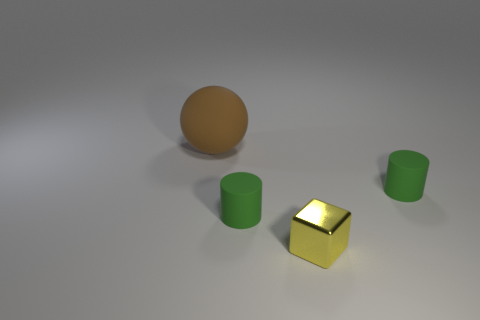Add 3 large green rubber cubes. How many objects exist? 7 Add 1 purple metallic balls. How many purple metallic balls exist? 1 Subtract 0 brown cylinders. How many objects are left? 4 Subtract all cubes. How many objects are left? 3 Subtract all cyan cylinders. Subtract all red spheres. How many cylinders are left? 2 Subtract all big matte objects. Subtract all small balls. How many objects are left? 3 Add 3 matte things. How many matte things are left? 6 